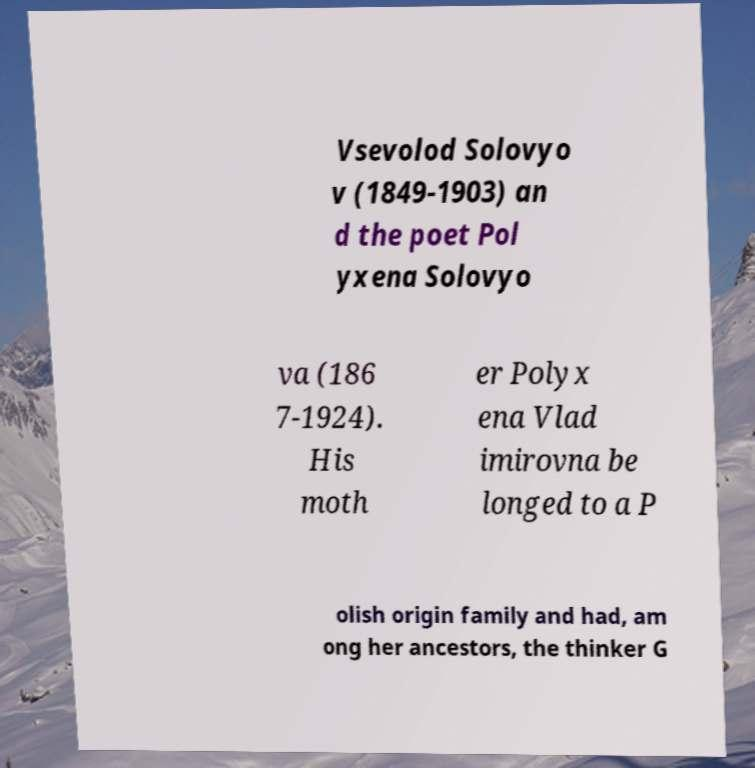Please read and relay the text visible in this image. What does it say? Vsevolod Solovyo v (1849-1903) an d the poet Pol yxena Solovyo va (186 7-1924). His moth er Polyx ena Vlad imirovna be longed to a P olish origin family and had, am ong her ancestors, the thinker G 